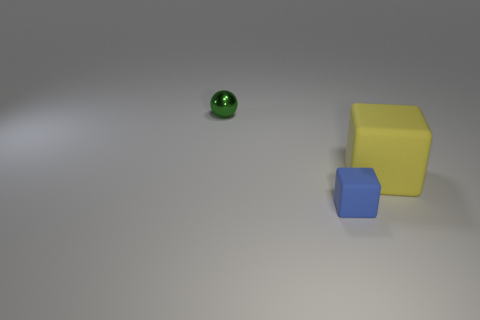What number of rubber blocks are there?
Your response must be concise. 2. The tiny thing that is in front of the small green metal thing is what color?
Offer a very short reply. Blue. The rubber cube that is behind the block left of the big rubber thing is what color?
Offer a very short reply. Yellow. What color is the matte object that is the same size as the metallic sphere?
Offer a very short reply. Blue. How many objects are behind the large matte thing and in front of the small green thing?
Provide a succinct answer. 0. There is a object that is right of the metallic ball and behind the tiny matte block; what material is it?
Offer a terse response. Rubber. Are there fewer small blue blocks to the right of the big yellow cube than matte objects that are right of the small green metal object?
Keep it short and to the point. Yes. The blue block that is made of the same material as the large yellow object is what size?
Your answer should be very brief. Small. Is there anything else of the same color as the sphere?
Your answer should be compact. No. Is the big yellow block made of the same material as the small thing behind the blue rubber block?
Provide a succinct answer. No. 